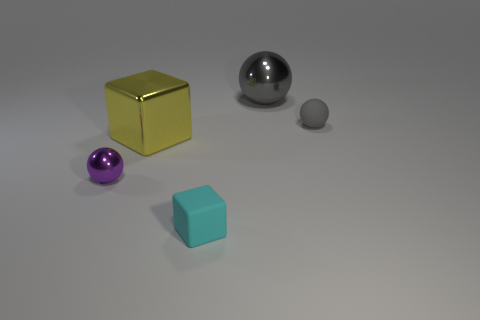There is a cyan thing that is the same size as the purple thing; what is its material?
Offer a terse response. Rubber. There is a block in front of the big yellow metallic block; what size is it?
Offer a very short reply. Small. There is a rubber object that is to the left of the gray metal sphere; is its size the same as the metal cube in front of the gray matte object?
Provide a short and direct response. No. What number of other cyan cubes are made of the same material as the cyan cube?
Your response must be concise. 0. What is the color of the rubber sphere?
Your answer should be very brief. Gray. Are there any tiny purple spheres to the right of the gray rubber object?
Keep it short and to the point. No. Do the rubber ball and the tiny rubber block have the same color?
Your answer should be compact. No. What number of tiny objects are the same color as the large metal block?
Provide a short and direct response. 0. There is a gray thing behind the tiny matte thing that is to the right of the rubber cube; how big is it?
Your answer should be very brief. Large. The cyan rubber thing is what shape?
Give a very brief answer. Cube. 